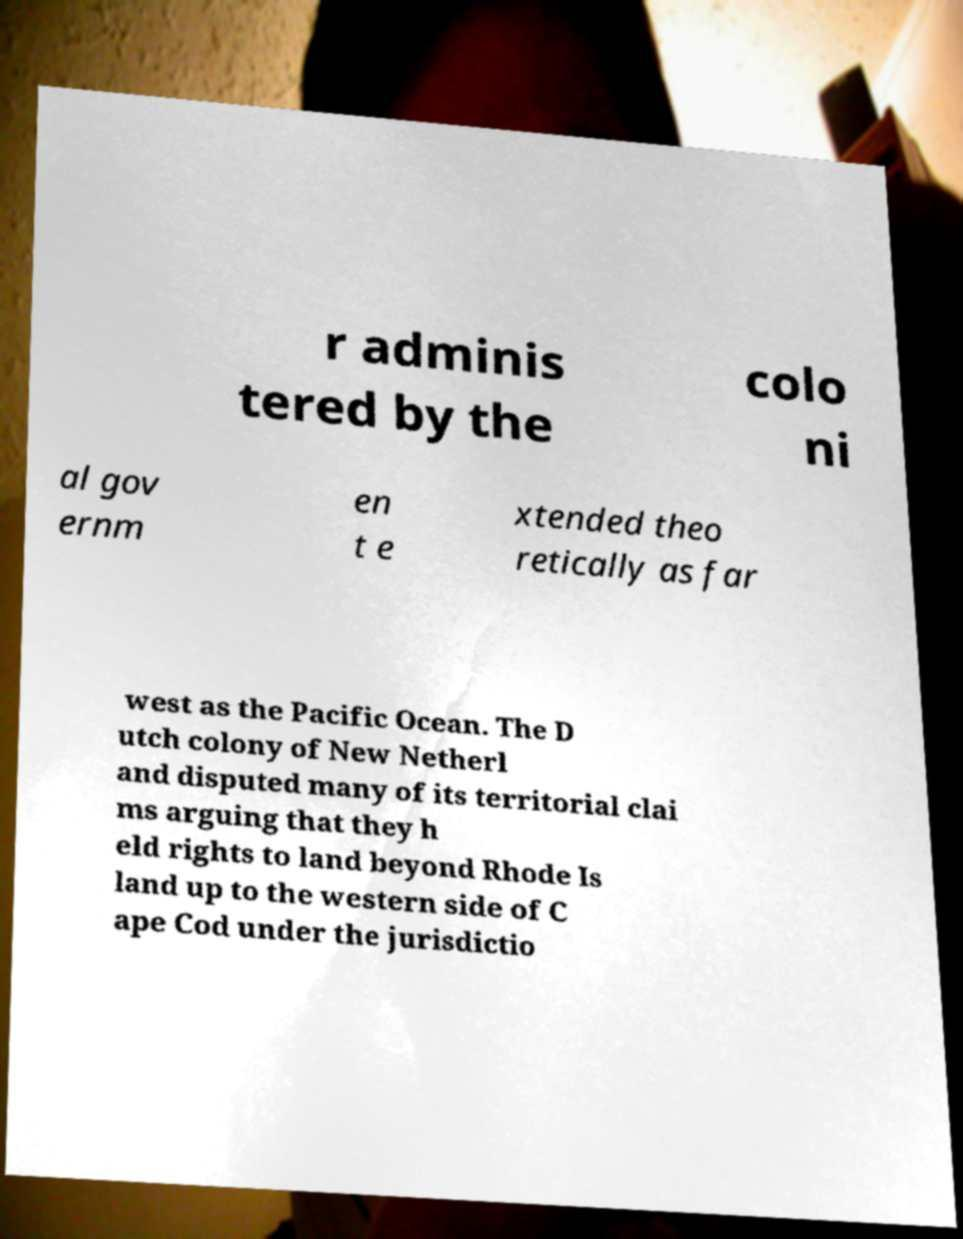Could you extract and type out the text from this image? r adminis tered by the colo ni al gov ernm en t e xtended theo retically as far west as the Pacific Ocean. The D utch colony of New Netherl and disputed many of its territorial clai ms arguing that they h eld rights to land beyond Rhode Is land up to the western side of C ape Cod under the jurisdictio 